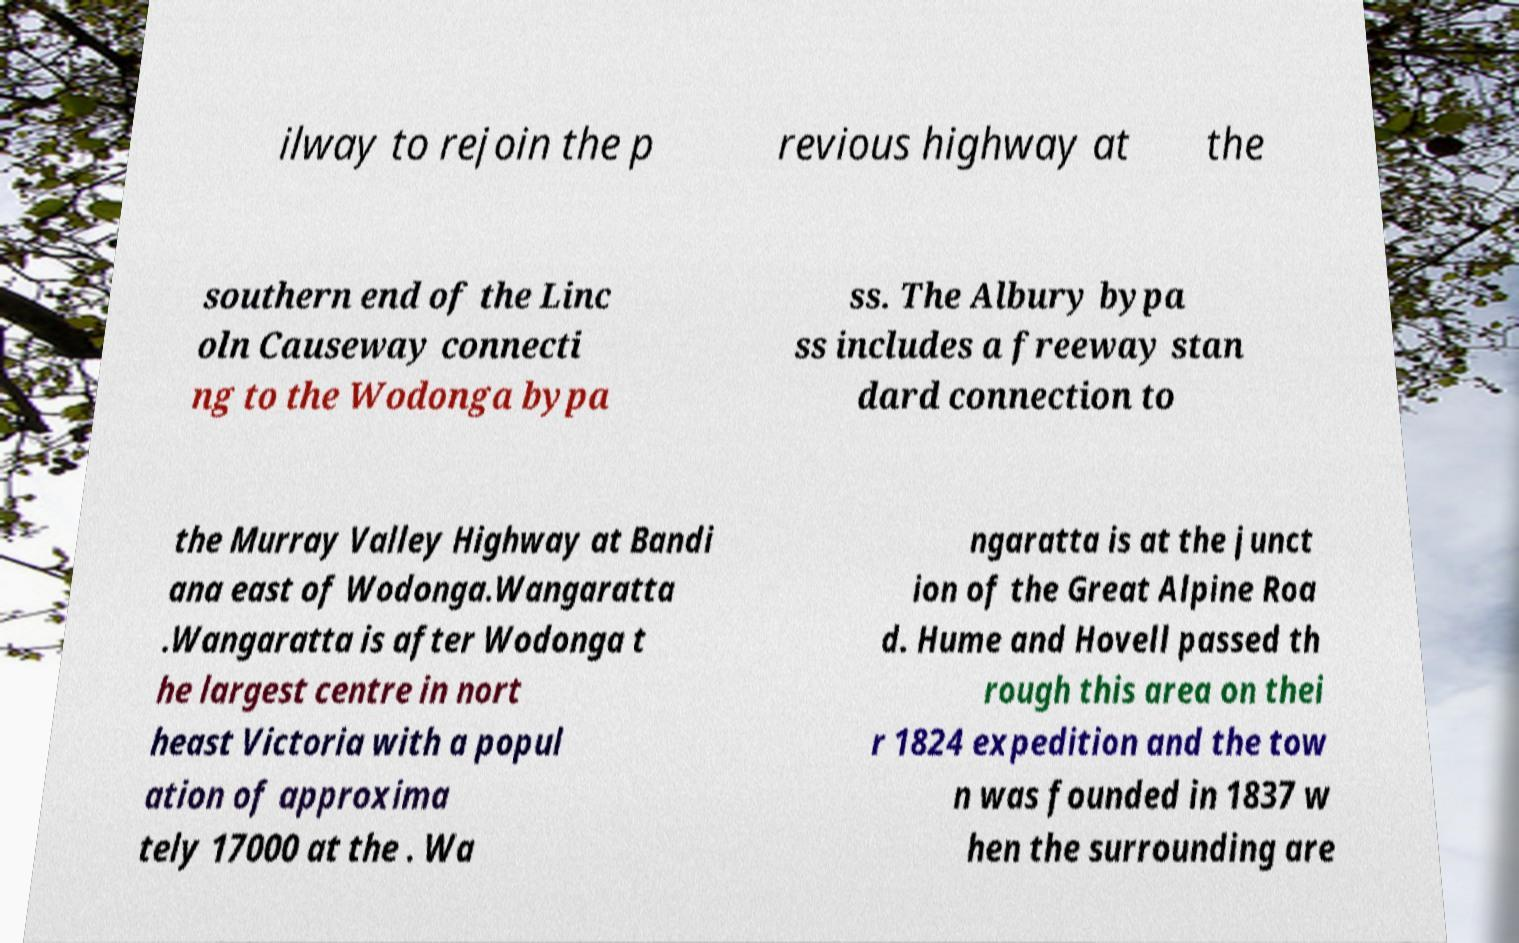What messages or text are displayed in this image? I need them in a readable, typed format. ilway to rejoin the p revious highway at the southern end of the Linc oln Causeway connecti ng to the Wodonga bypa ss. The Albury bypa ss includes a freeway stan dard connection to the Murray Valley Highway at Bandi ana east of Wodonga.Wangaratta .Wangaratta is after Wodonga t he largest centre in nort heast Victoria with a popul ation of approxima tely 17000 at the . Wa ngaratta is at the junct ion of the Great Alpine Roa d. Hume and Hovell passed th rough this area on thei r 1824 expedition and the tow n was founded in 1837 w hen the surrounding are 